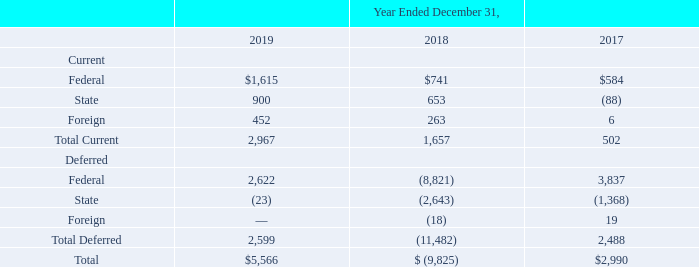Note 18. Income Taxes
The Tax Cuts and Jobs Act, or the Tax Act, was signed into law on December 22, 2017. This legislation made significant changes in U.S. tax law, including a reduction in the corporate tax rate, changes to net operating loss carryforwards and carrybacks and a repeal of the corporate alternative minimum tax. The legislation reduced the U.S. corporate income tax rate from 35% to 21%. As a result of the enacted Tax Act, we were required to revalue deferred tax assets and liabilities at the rate in effect when the deferred tax balances are scheduled to reverse. This revaluation resulted in an additional $8.8 million of income tax expense and a corresponding reduction in the deferred tax asset which was recorded during the year ended December 31, 2017.
Additionally, on December 22, 2017, the Securities and Exchange Commission staff issued Staff Accounting Bulletin No. 118, or SAB 118, to address the application of GAAP in situations when a registrant does not have the necessary information available, prepared, or analyzed in reasonable detail to complete the accounting for certain income tax effects of the Tax Act. Specifically, SAB 118 provides a measurement period for companies to evaluate the impacts of the Tax Act on their financial statements. We completed the accounting for the tax effects of the Tax Act during the three months ended September 30, 2018 and decreased our provisional estimate from $8.8 million to $8.7 million.
The components of our income tax expense are as follows (in thousands):
When was the The Tax Cuts and Jobs Act, or the Tax Act, signed into law? December 22, 2017. Which years does the table provide information for the components of the company's income tax expense? 2019, 2018, 2017. What was the total income tax expense in 2019?
Answer scale should be: thousand. 5,566. What was the change in current State income tax expense between 2018 and 2019?
Answer scale should be: thousand. 900-653
Answer: 247. What was the change in total deferred income tax expense between 2017 and 2019?
Answer scale should be: thousand. 2,599-2,488
Answer: 111. What was the percentage change in the total income tax expense between 2017 and 2019?
Answer scale should be: percent. (5,566-2,990)/2,990
Answer: 86.15. 